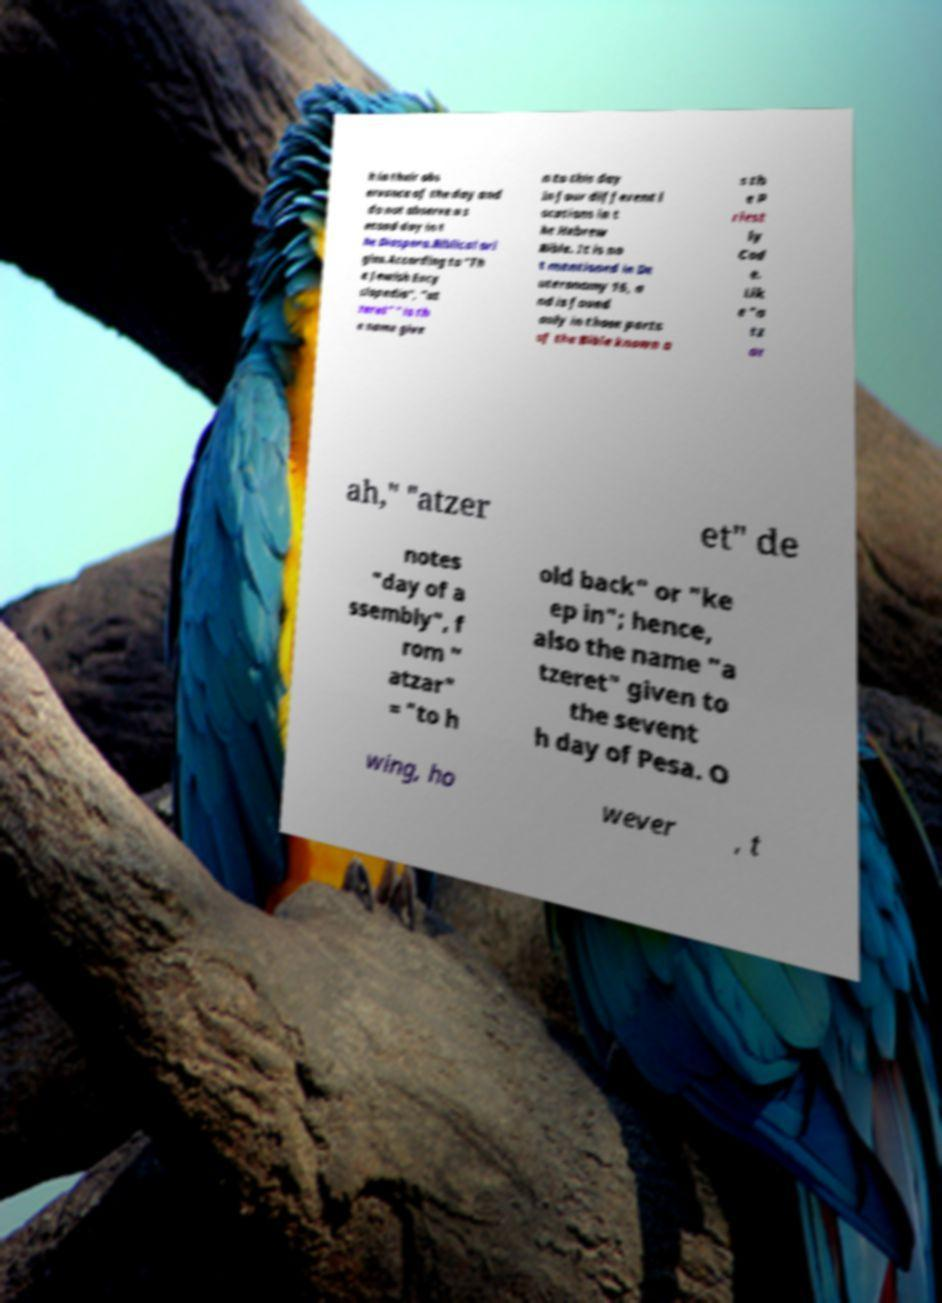Please read and relay the text visible in this image. What does it say? h in their obs ervance of the day and do not observe a s econd day in t he Diaspora.Biblical ori gins.According to "Th e Jewish Ency clopedia", "at zeret" " is th e name give n to this day in four different l ocations in t he Hebrew Bible. It is no t mentioned in De uteronomy 16, a nd is found only in those parts of the Bible known a s th e P riest ly Cod e. Lik e "a tz ar ah," "atzer et" de notes "day of a ssembly", f rom " atzar" = "to h old back" or "ke ep in"; hence, also the name "a tzeret" given to the sevent h day of Pesa. O wing, ho wever , t 